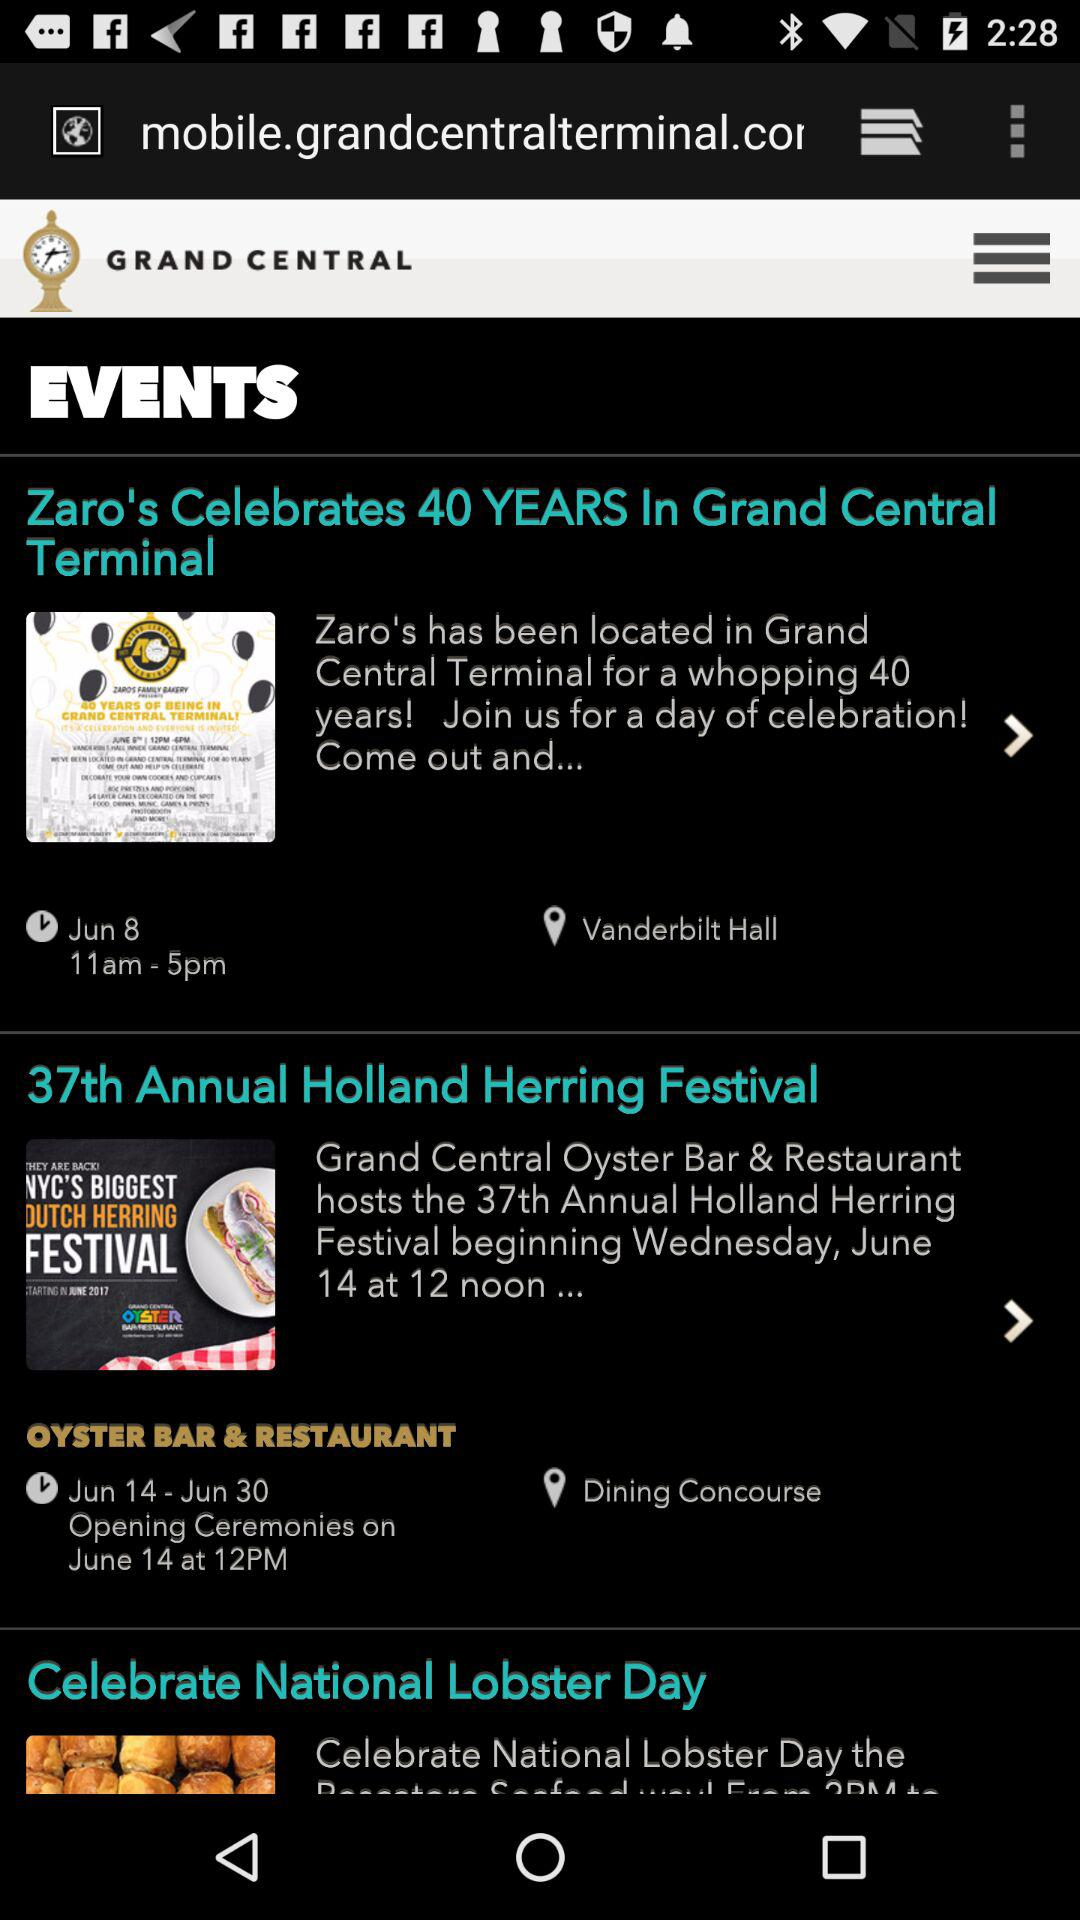What is the venue of the "37th Annual Holland Herring Festival"? The venue is "OYSTER BAR & RESTAURANT". 